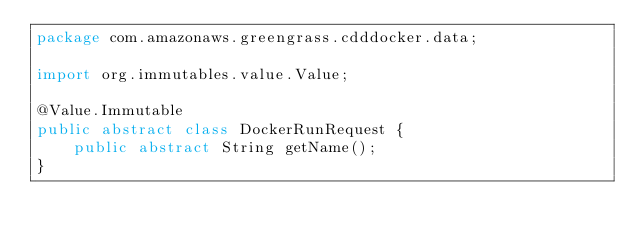<code> <loc_0><loc_0><loc_500><loc_500><_Java_>package com.amazonaws.greengrass.cdddocker.data;

import org.immutables.value.Value;

@Value.Immutable
public abstract class DockerRunRequest {
    public abstract String getName();
}
</code> 